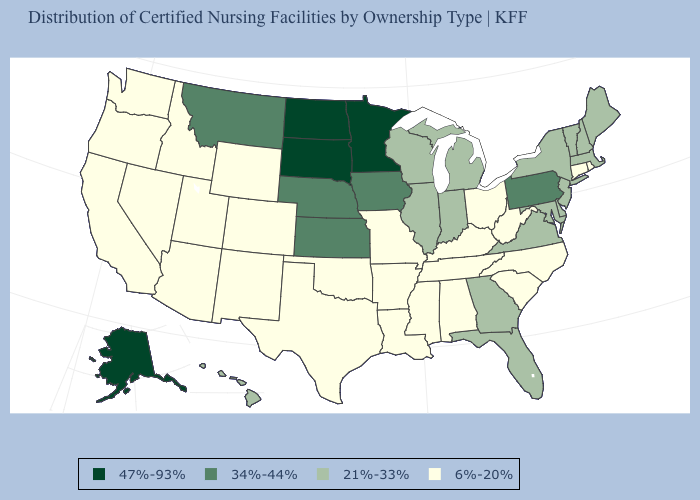Name the states that have a value in the range 21%-33%?
Write a very short answer. Delaware, Florida, Georgia, Hawaii, Illinois, Indiana, Maine, Maryland, Massachusetts, Michigan, New Hampshire, New Jersey, New York, Vermont, Virginia, Wisconsin. Which states have the lowest value in the West?
Be succinct. Arizona, California, Colorado, Idaho, Nevada, New Mexico, Oregon, Utah, Washington, Wyoming. What is the value of Idaho?
Concise answer only. 6%-20%. Does the map have missing data?
Concise answer only. No. Does Alaska have the lowest value in the West?
Be succinct. No. Does the map have missing data?
Quick response, please. No. Does Minnesota have the highest value in the USA?
Be succinct. Yes. What is the highest value in the USA?
Quick response, please. 47%-93%. What is the highest value in the West ?
Give a very brief answer. 47%-93%. What is the value of Indiana?
Be succinct. 21%-33%. How many symbols are there in the legend?
Quick response, please. 4. Which states have the highest value in the USA?
Answer briefly. Alaska, Minnesota, North Dakota, South Dakota. Name the states that have a value in the range 21%-33%?
Keep it brief. Delaware, Florida, Georgia, Hawaii, Illinois, Indiana, Maine, Maryland, Massachusetts, Michigan, New Hampshire, New Jersey, New York, Vermont, Virginia, Wisconsin. Does Maryland have the same value as Nebraska?
Give a very brief answer. No. What is the value of South Carolina?
Be succinct. 6%-20%. 